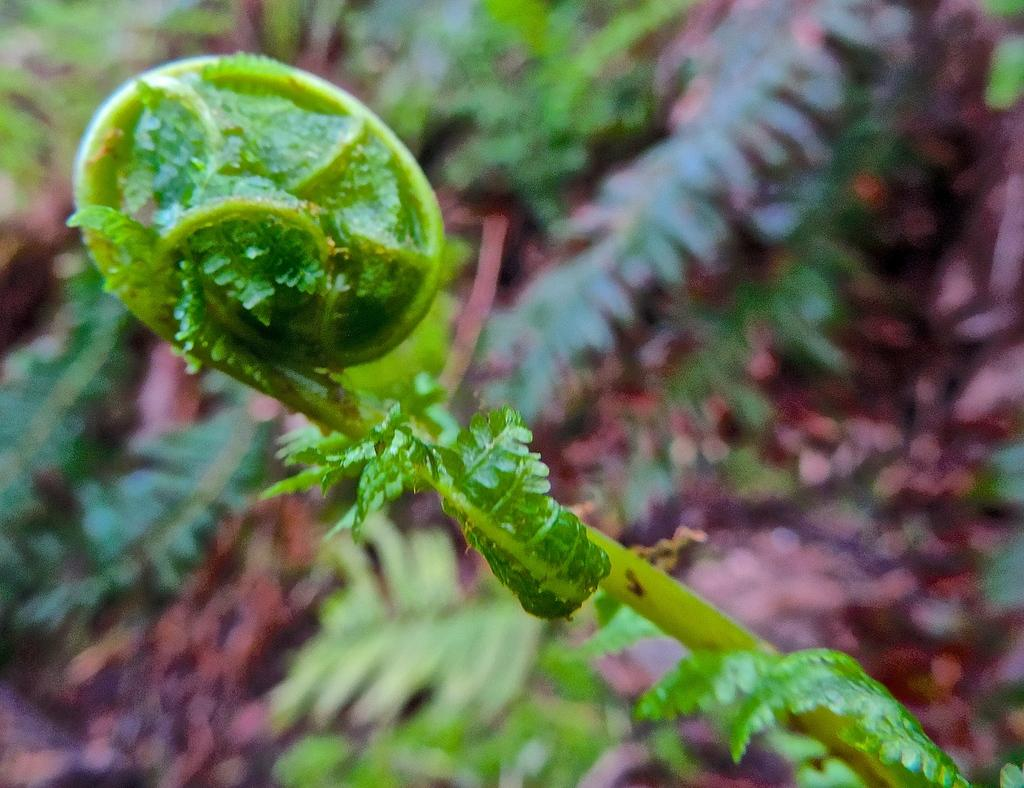What type of vegetation can be seen in the image? There are plants and grass in the image. Can you describe the leaves visible at the top of the image? Yes, leaves are visible at the top of the image. What type of table is shown in the image? There is no table present in the image; it features plants, grass, and leaves. Can you describe the locket hanging from the leaves in the image? There is no locket present in the image; it only features plants, grass, and leaves. 